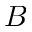Convert formula to latex. <formula><loc_0><loc_0><loc_500><loc_500>B</formula> 